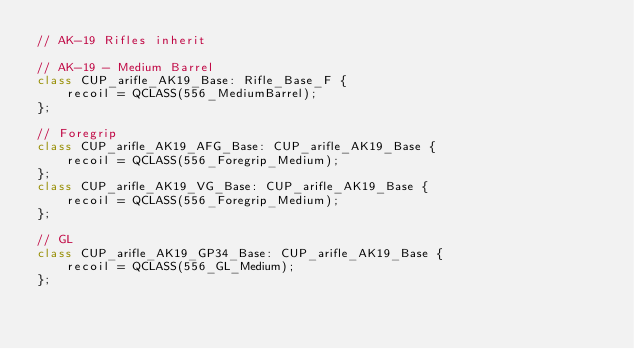<code> <loc_0><loc_0><loc_500><loc_500><_C++_>// AK-19 Rifles inherit

// AK-19 - Medium Barrel
class CUP_arifle_AK19_Base: Rifle_Base_F {
    recoil = QCLASS(556_MediumBarrel);
};

// Foregrip
class CUP_arifle_AK19_AFG_Base: CUP_arifle_AK19_Base {
    recoil = QCLASS(556_Foregrip_Medium);
};
class CUP_arifle_AK19_VG_Base: CUP_arifle_AK19_Base {
    recoil = QCLASS(556_Foregrip_Medium);
};

// GL
class CUP_arifle_AK19_GP34_Base: CUP_arifle_AK19_Base {
    recoil = QCLASS(556_GL_Medium);
};
</code> 